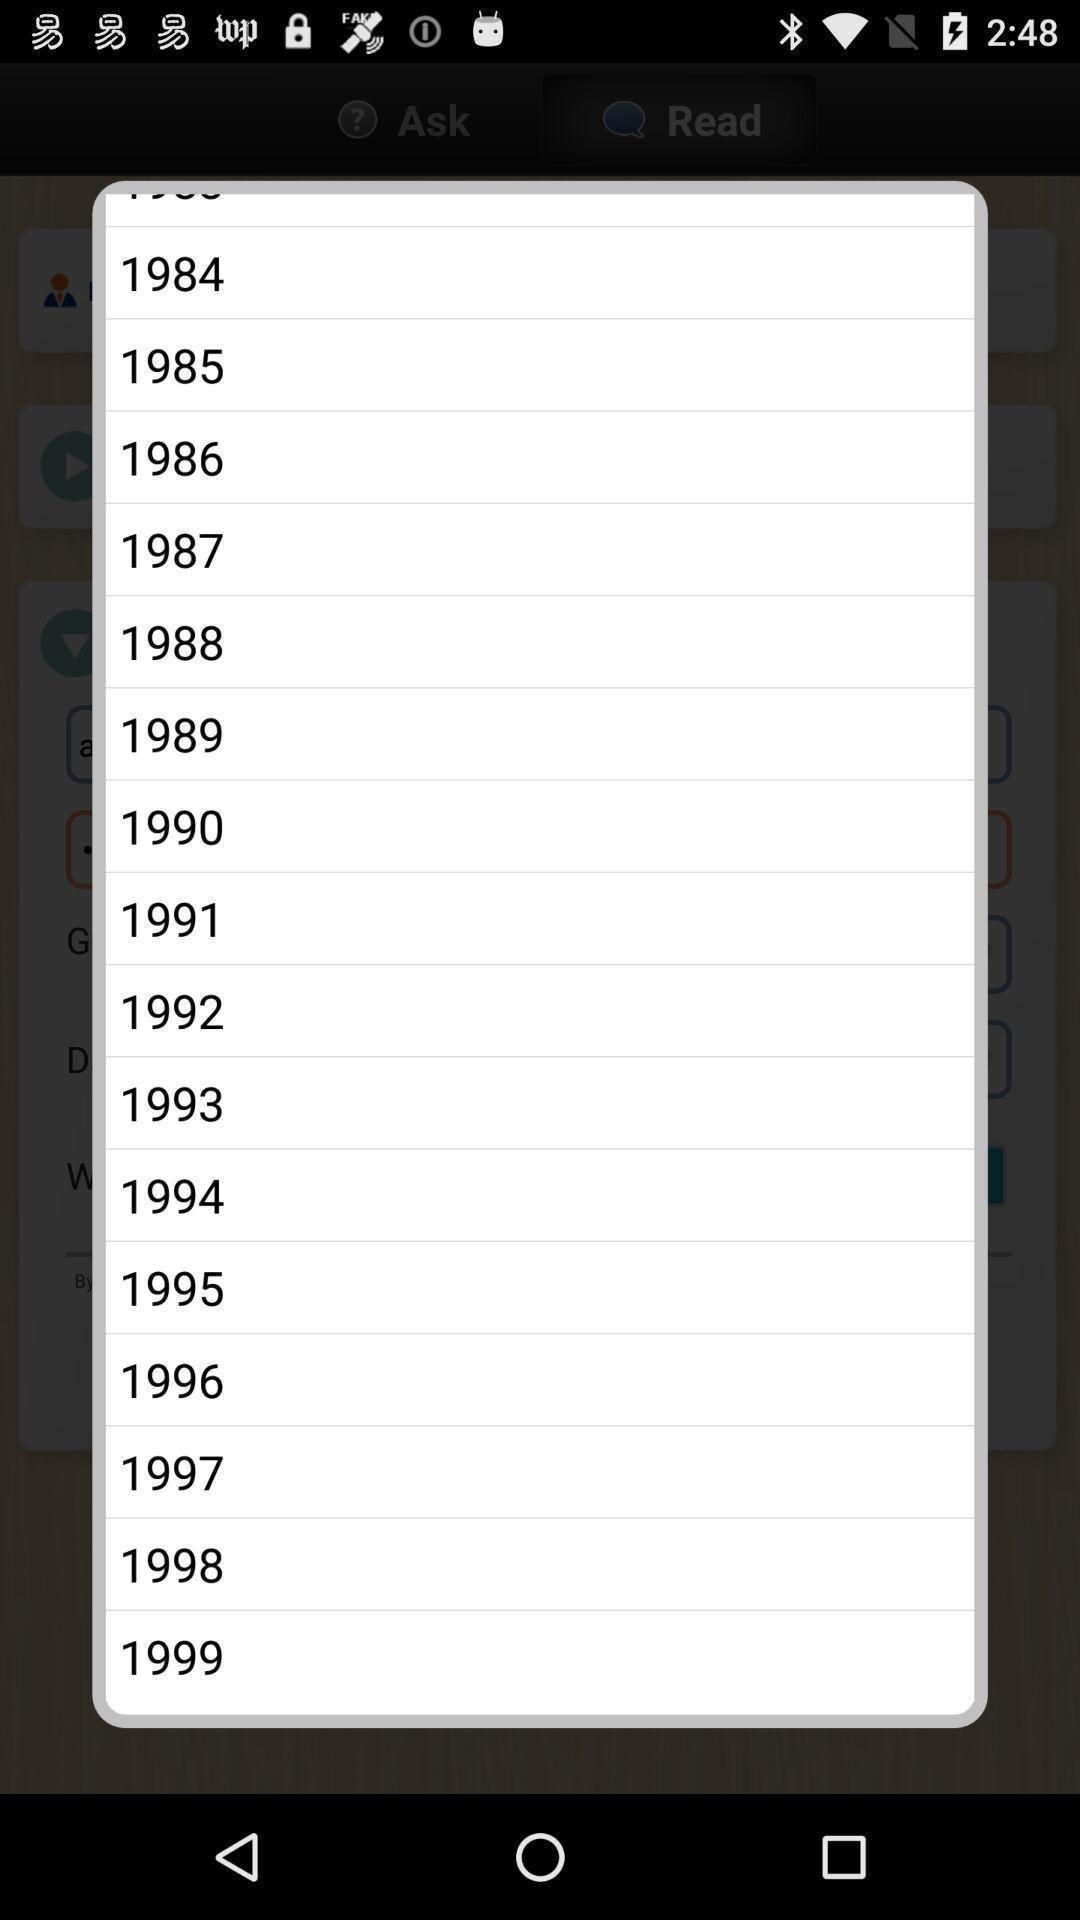Describe the visual elements of this screenshot. Popup displaying different options for selecting year in health application. 